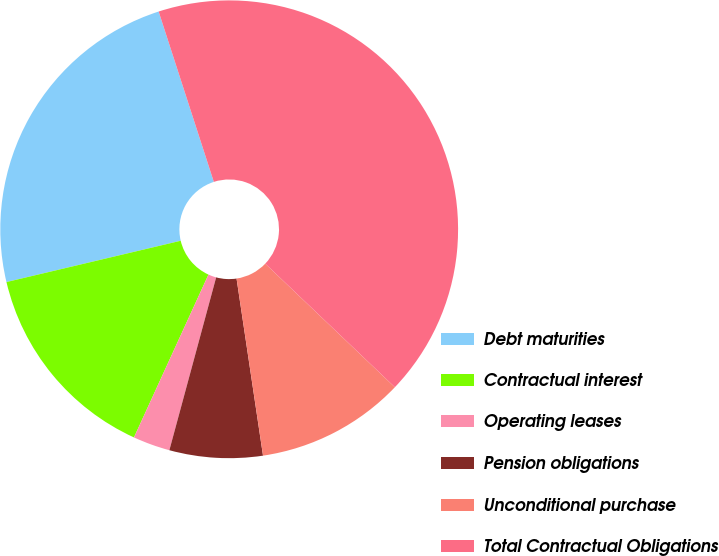Convert chart to OTSL. <chart><loc_0><loc_0><loc_500><loc_500><pie_chart><fcel>Debt maturities<fcel>Contractual interest<fcel>Operating leases<fcel>Pension obligations<fcel>Unconditional purchase<fcel>Total Contractual Obligations<nl><fcel>23.72%<fcel>14.47%<fcel>2.62%<fcel>6.57%<fcel>10.52%<fcel>42.11%<nl></chart> 